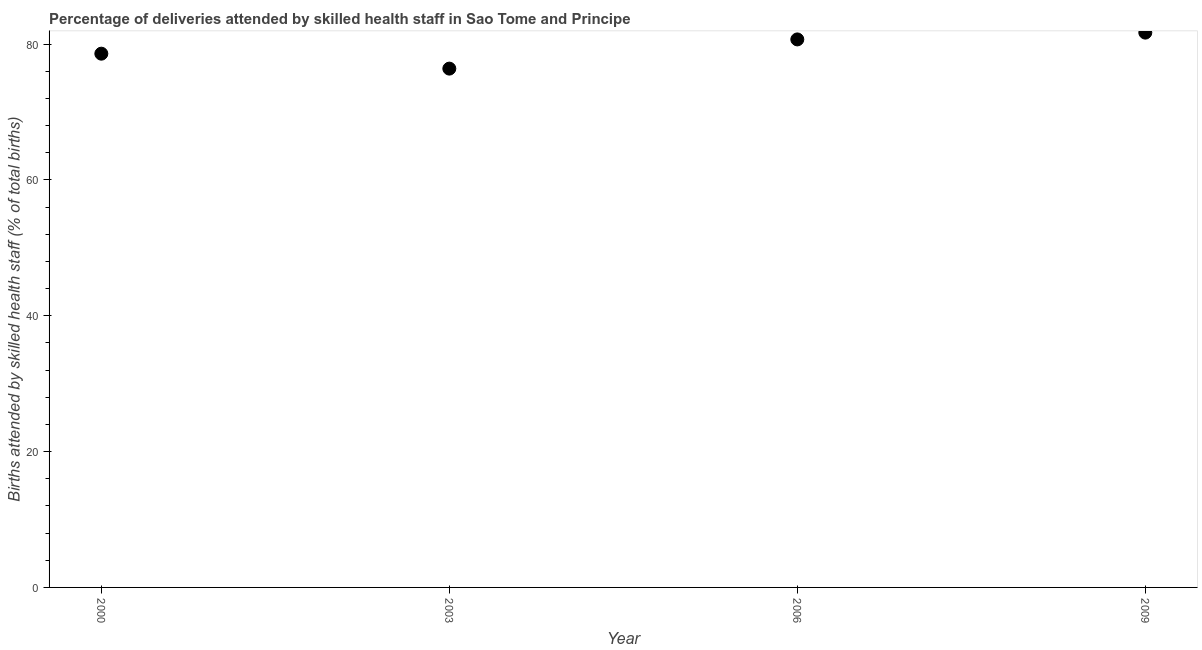What is the number of births attended by skilled health staff in 2003?
Your answer should be very brief. 76.4. Across all years, what is the maximum number of births attended by skilled health staff?
Provide a short and direct response. 81.7. Across all years, what is the minimum number of births attended by skilled health staff?
Provide a short and direct response. 76.4. In which year was the number of births attended by skilled health staff minimum?
Make the answer very short. 2003. What is the sum of the number of births attended by skilled health staff?
Your answer should be very brief. 317.4. What is the difference between the number of births attended by skilled health staff in 2003 and 2009?
Offer a terse response. -5.3. What is the average number of births attended by skilled health staff per year?
Keep it short and to the point. 79.35. What is the median number of births attended by skilled health staff?
Ensure brevity in your answer.  79.65. What is the ratio of the number of births attended by skilled health staff in 2003 to that in 2009?
Give a very brief answer. 0.94. Is the difference between the number of births attended by skilled health staff in 2000 and 2003 greater than the difference between any two years?
Your answer should be very brief. No. Is the sum of the number of births attended by skilled health staff in 2000 and 2006 greater than the maximum number of births attended by skilled health staff across all years?
Make the answer very short. Yes. What is the difference between the highest and the lowest number of births attended by skilled health staff?
Keep it short and to the point. 5.3. How many dotlines are there?
Your answer should be very brief. 1. How many years are there in the graph?
Keep it short and to the point. 4. What is the difference between two consecutive major ticks on the Y-axis?
Give a very brief answer. 20. Are the values on the major ticks of Y-axis written in scientific E-notation?
Your response must be concise. No. Does the graph contain any zero values?
Your response must be concise. No. Does the graph contain grids?
Keep it short and to the point. No. What is the title of the graph?
Ensure brevity in your answer.  Percentage of deliveries attended by skilled health staff in Sao Tome and Principe. What is the label or title of the Y-axis?
Ensure brevity in your answer.  Births attended by skilled health staff (% of total births). What is the Births attended by skilled health staff (% of total births) in 2000?
Ensure brevity in your answer.  78.6. What is the Births attended by skilled health staff (% of total births) in 2003?
Ensure brevity in your answer.  76.4. What is the Births attended by skilled health staff (% of total births) in 2006?
Your answer should be compact. 80.7. What is the Births attended by skilled health staff (% of total births) in 2009?
Your response must be concise. 81.7. What is the difference between the Births attended by skilled health staff (% of total births) in 2000 and 2003?
Keep it short and to the point. 2.2. What is the difference between the Births attended by skilled health staff (% of total births) in 2003 and 2006?
Keep it short and to the point. -4.3. What is the ratio of the Births attended by skilled health staff (% of total births) in 2000 to that in 2006?
Make the answer very short. 0.97. What is the ratio of the Births attended by skilled health staff (% of total births) in 2000 to that in 2009?
Provide a short and direct response. 0.96. What is the ratio of the Births attended by skilled health staff (% of total births) in 2003 to that in 2006?
Ensure brevity in your answer.  0.95. What is the ratio of the Births attended by skilled health staff (% of total births) in 2003 to that in 2009?
Your answer should be compact. 0.94. 